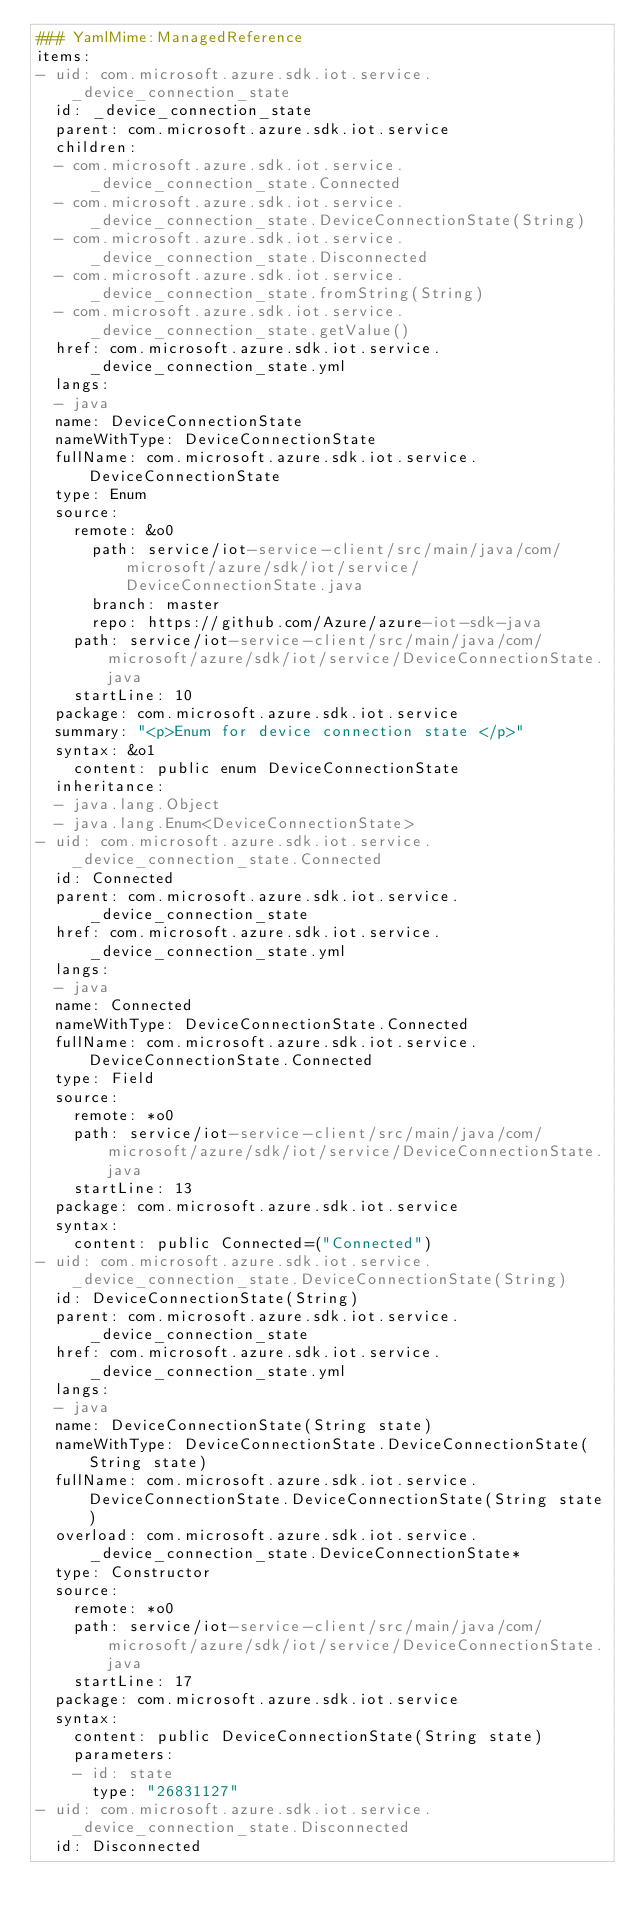Convert code to text. <code><loc_0><loc_0><loc_500><loc_500><_YAML_>### YamlMime:ManagedReference
items:
- uid: com.microsoft.azure.sdk.iot.service._device_connection_state
  id: _device_connection_state
  parent: com.microsoft.azure.sdk.iot.service
  children:
  - com.microsoft.azure.sdk.iot.service._device_connection_state.Connected
  - com.microsoft.azure.sdk.iot.service._device_connection_state.DeviceConnectionState(String)
  - com.microsoft.azure.sdk.iot.service._device_connection_state.Disconnected
  - com.microsoft.azure.sdk.iot.service._device_connection_state.fromString(String)
  - com.microsoft.azure.sdk.iot.service._device_connection_state.getValue()
  href: com.microsoft.azure.sdk.iot.service._device_connection_state.yml
  langs:
  - java
  name: DeviceConnectionState
  nameWithType: DeviceConnectionState
  fullName: com.microsoft.azure.sdk.iot.service.DeviceConnectionState
  type: Enum
  source:
    remote: &o0
      path: service/iot-service-client/src/main/java/com/microsoft/azure/sdk/iot/service/DeviceConnectionState.java
      branch: master
      repo: https://github.com/Azure/azure-iot-sdk-java
    path: service/iot-service-client/src/main/java/com/microsoft/azure/sdk/iot/service/DeviceConnectionState.java
    startLine: 10
  package: com.microsoft.azure.sdk.iot.service
  summary: "<p>Enum for device connection state </p>"
  syntax: &o1
    content: public enum DeviceConnectionState
  inheritance:
  - java.lang.Object
  - java.lang.Enum<DeviceConnectionState>
- uid: com.microsoft.azure.sdk.iot.service._device_connection_state.Connected
  id: Connected
  parent: com.microsoft.azure.sdk.iot.service._device_connection_state
  href: com.microsoft.azure.sdk.iot.service._device_connection_state.yml
  langs:
  - java
  name: Connected
  nameWithType: DeviceConnectionState.Connected
  fullName: com.microsoft.azure.sdk.iot.service.DeviceConnectionState.Connected
  type: Field
  source:
    remote: *o0
    path: service/iot-service-client/src/main/java/com/microsoft/azure/sdk/iot/service/DeviceConnectionState.java
    startLine: 13
  package: com.microsoft.azure.sdk.iot.service
  syntax:
    content: public Connected=("Connected")
- uid: com.microsoft.azure.sdk.iot.service._device_connection_state.DeviceConnectionState(String)
  id: DeviceConnectionState(String)
  parent: com.microsoft.azure.sdk.iot.service._device_connection_state
  href: com.microsoft.azure.sdk.iot.service._device_connection_state.yml
  langs:
  - java
  name: DeviceConnectionState(String state)
  nameWithType: DeviceConnectionState.DeviceConnectionState(String state)
  fullName: com.microsoft.azure.sdk.iot.service.DeviceConnectionState.DeviceConnectionState(String state)
  overload: com.microsoft.azure.sdk.iot.service._device_connection_state.DeviceConnectionState*
  type: Constructor
  source:
    remote: *o0
    path: service/iot-service-client/src/main/java/com/microsoft/azure/sdk/iot/service/DeviceConnectionState.java
    startLine: 17
  package: com.microsoft.azure.sdk.iot.service
  syntax:
    content: public DeviceConnectionState(String state)
    parameters:
    - id: state
      type: "26831127"
- uid: com.microsoft.azure.sdk.iot.service._device_connection_state.Disconnected
  id: Disconnected</code> 